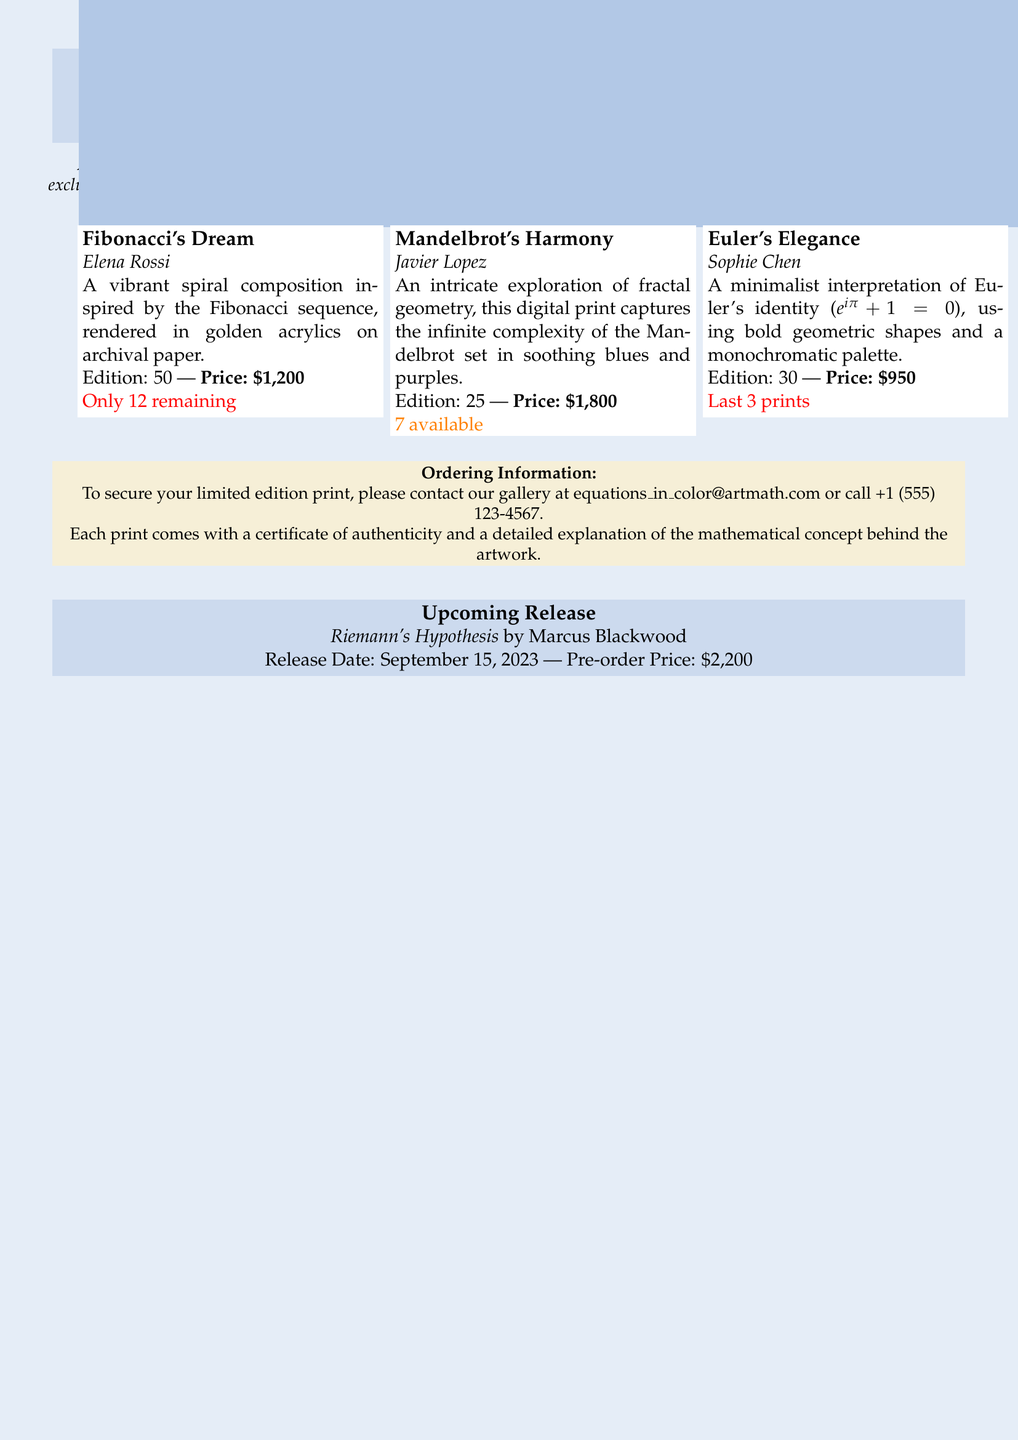What is the title of the first artwork? The title of the first artwork listed in the document is "Fibonacci's Dream."
Answer: Fibonacci's Dream Who created "Mandelbrot's Harmony"? This artwork was created by Javier Lopez, as mentioned in the document.
Answer: Javier Lopez How many editions of "Euler's Elegance" are available? The document states that there are only 3 prints left of "Euler's Elegance."
Answer: Last 3 prints What is the release date for "Riemann's Hypothesis"? The release date is specified in the document as September 15, 2023.
Answer: September 15, 2023 What is the pre-order price for "Riemann's Hypothesis"? The pre-order price is indicated as $2,200 in the document.
Answer: $2,200 How many editions of "Fibonacci's Dream" are there? The document notes that there are a total of 50 editions available for "Fibonacci's Dream."
Answer: 50 What mathematical concept does "Euler's Elegance" reference? "Euler's Elegance" references Euler's identity, which is highlighted in the document.
Answer: Euler's identity What is included with each print? The document mentions that each print comes with a certificate of authenticity and a detailed explanation.
Answer: Certificate of authenticity and detailed explanation 